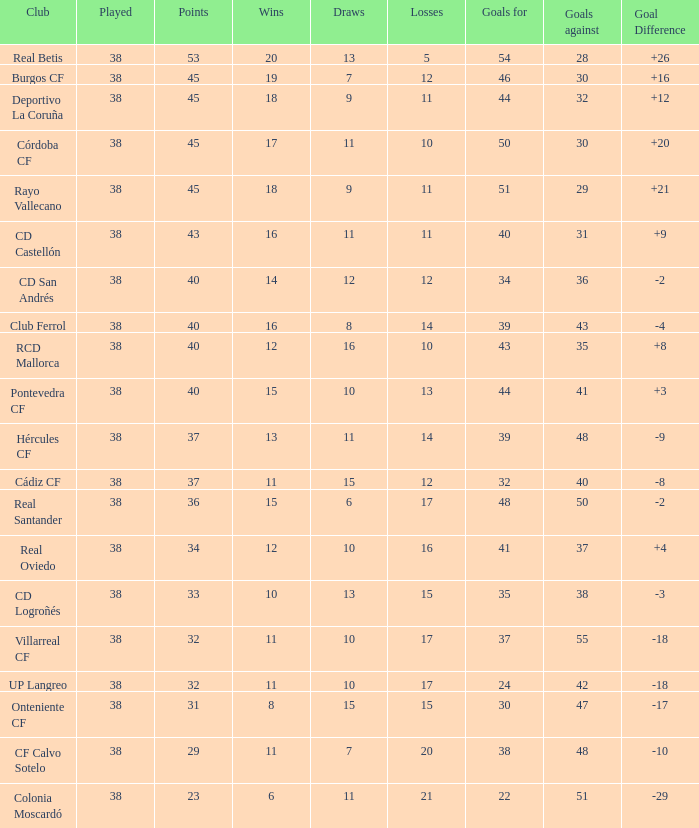Calculate the average draws for situations where the goal difference is over -3, goals against stands at 30, and points surpass 45. None. 